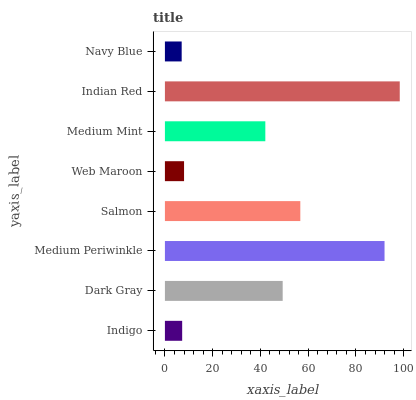Is Navy Blue the minimum?
Answer yes or no. Yes. Is Indian Red the maximum?
Answer yes or no. Yes. Is Dark Gray the minimum?
Answer yes or no. No. Is Dark Gray the maximum?
Answer yes or no. No. Is Dark Gray greater than Indigo?
Answer yes or no. Yes. Is Indigo less than Dark Gray?
Answer yes or no. Yes. Is Indigo greater than Dark Gray?
Answer yes or no. No. Is Dark Gray less than Indigo?
Answer yes or no. No. Is Dark Gray the high median?
Answer yes or no. Yes. Is Medium Mint the low median?
Answer yes or no. Yes. Is Web Maroon the high median?
Answer yes or no. No. Is Navy Blue the low median?
Answer yes or no. No. 